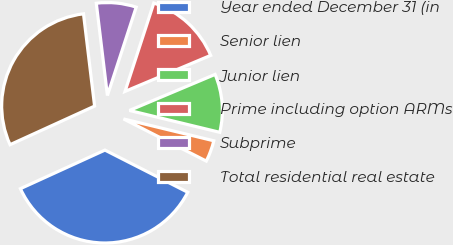Convert chart to OTSL. <chart><loc_0><loc_0><loc_500><loc_500><pie_chart><fcel>Year ended December 31 (in<fcel>Senior lien<fcel>Junior lien<fcel>Prime including option ARMs<fcel>Subprime<fcel>Total residential real estate<nl><fcel>35.69%<fcel>3.72%<fcel>10.12%<fcel>13.65%<fcel>6.92%<fcel>29.91%<nl></chart> 